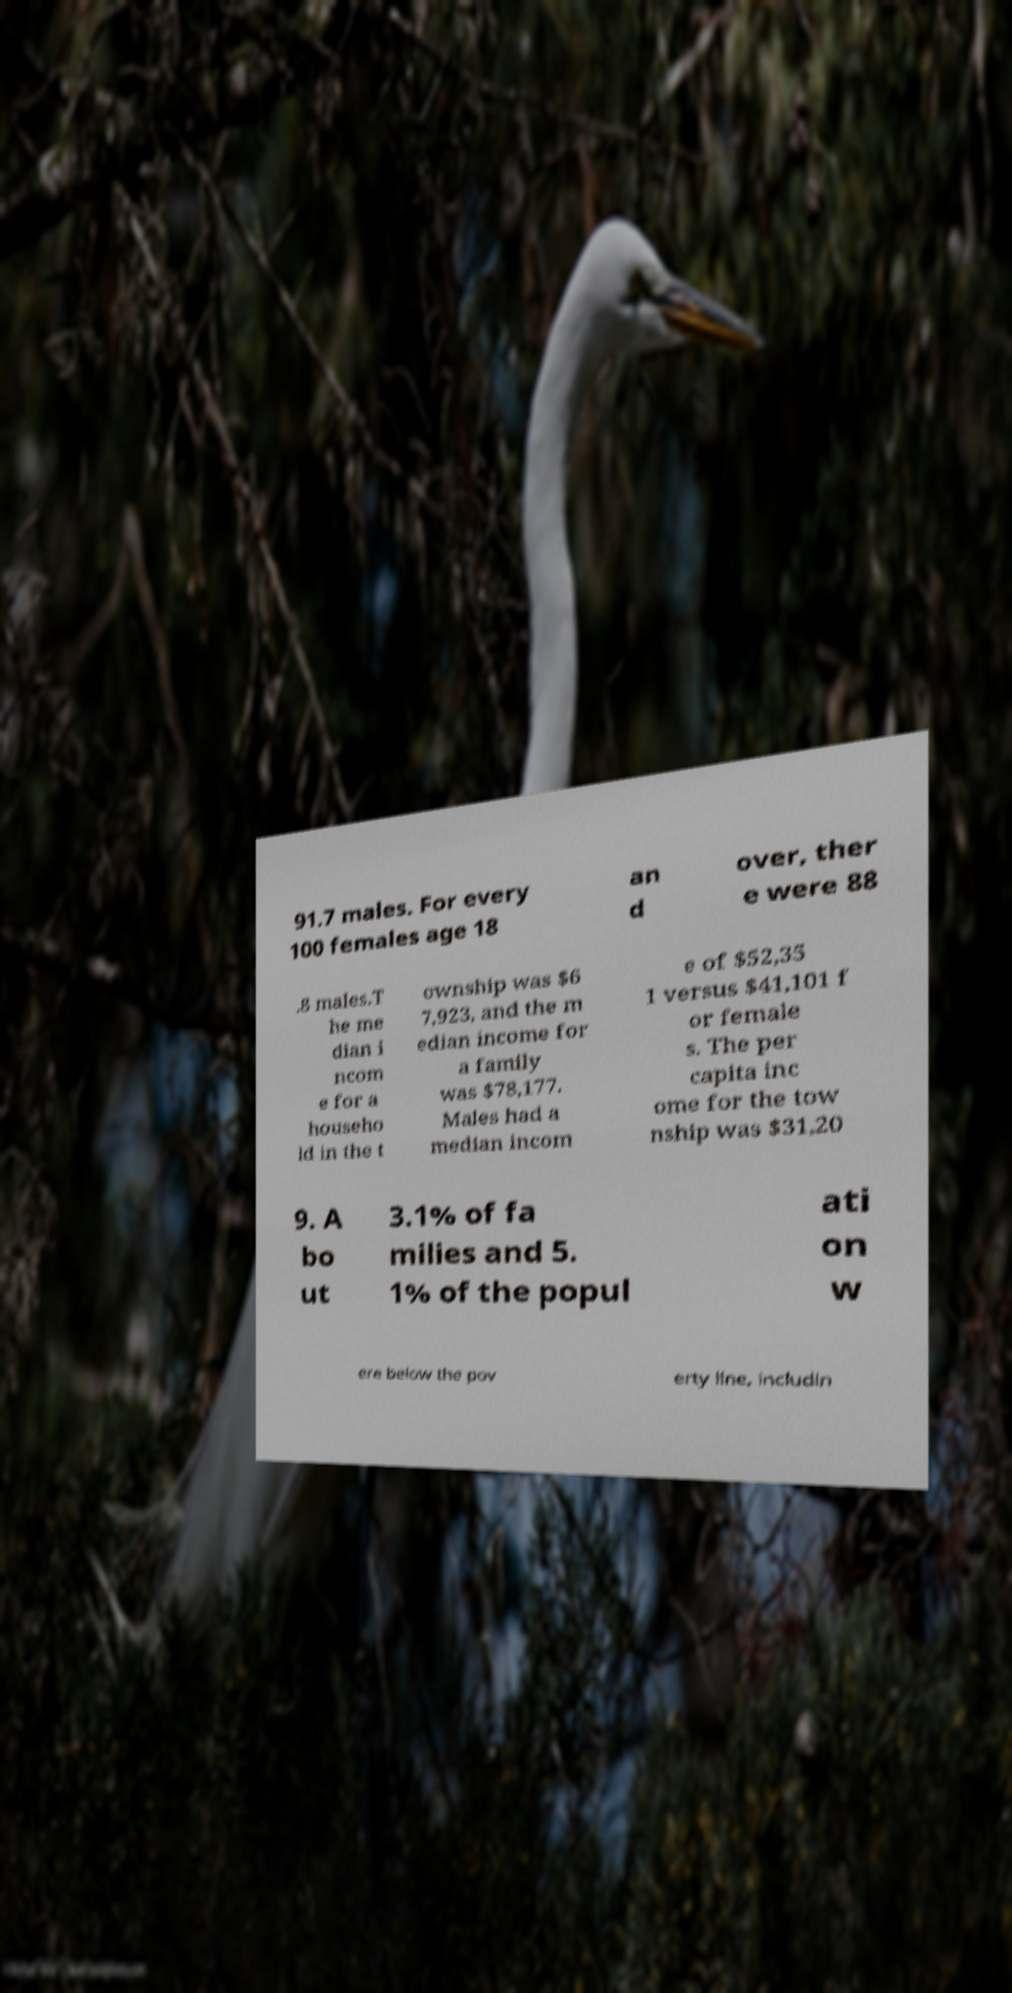I need the written content from this picture converted into text. Can you do that? 91.7 males. For every 100 females age 18 an d over, ther e were 88 .8 males.T he me dian i ncom e for a househo ld in the t ownship was $6 7,923, and the m edian income for a family was $78,177. Males had a median incom e of $52,35 1 versus $41,101 f or female s. The per capita inc ome for the tow nship was $31,20 9. A bo ut 3.1% of fa milies and 5. 1% of the popul ati on w ere below the pov erty line, includin 